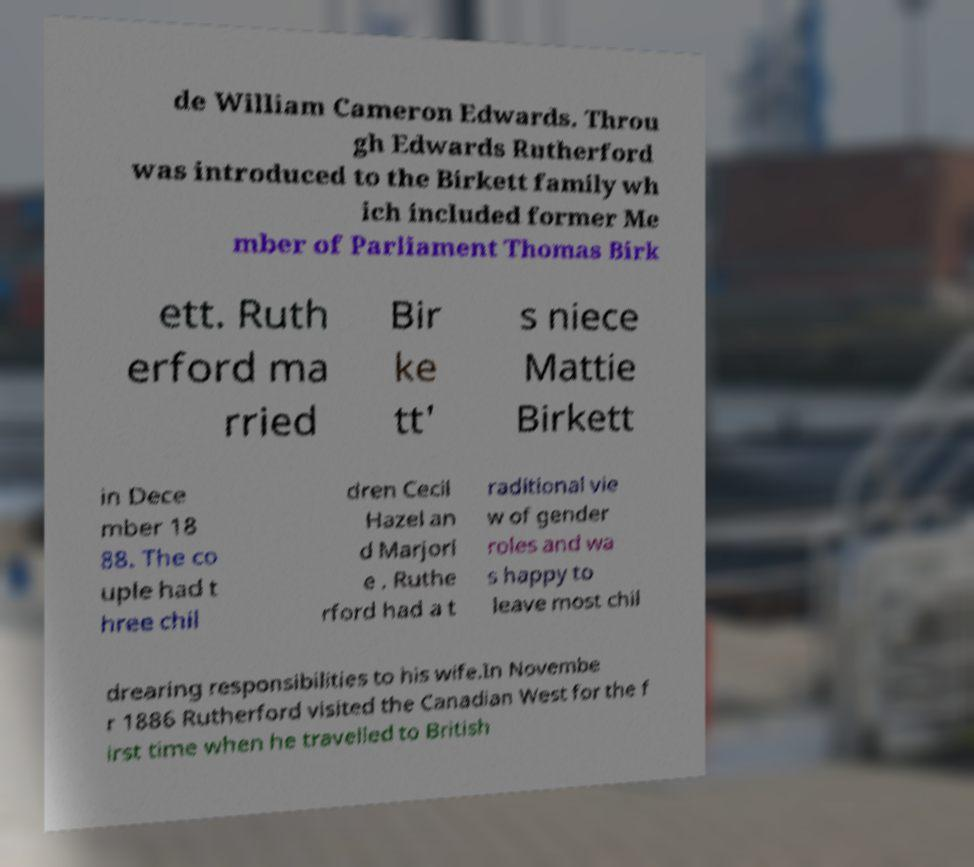Can you accurately transcribe the text from the provided image for me? de William Cameron Edwards. Throu gh Edwards Rutherford was introduced to the Birkett family wh ich included former Me mber of Parliament Thomas Birk ett. Ruth erford ma rried Bir ke tt' s niece Mattie Birkett in Dece mber 18 88. The co uple had t hree chil dren Cecil Hazel an d Marjori e . Ruthe rford had a t raditional vie w of gender roles and wa s happy to leave most chil drearing responsibilities to his wife.In Novembe r 1886 Rutherford visited the Canadian West for the f irst time when he travelled to British 